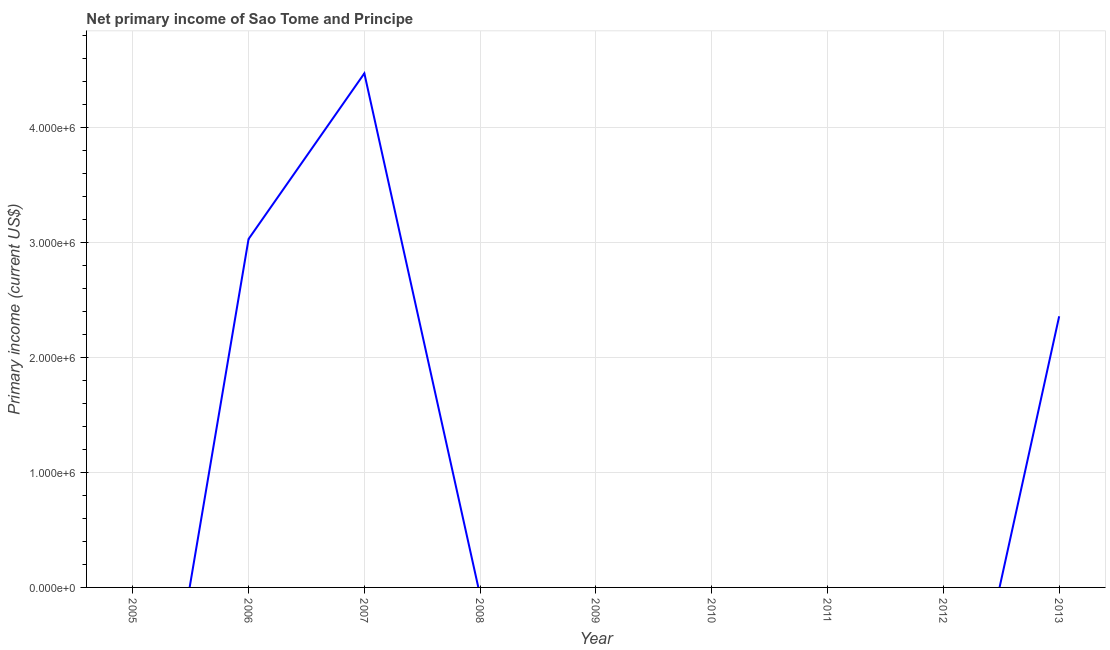What is the amount of primary income in 2013?
Your answer should be very brief. 2.36e+06. Across all years, what is the maximum amount of primary income?
Give a very brief answer. 4.47e+06. Across all years, what is the minimum amount of primary income?
Ensure brevity in your answer.  0. In which year was the amount of primary income maximum?
Keep it short and to the point. 2007. What is the sum of the amount of primary income?
Provide a short and direct response. 9.87e+06. What is the difference between the amount of primary income in 2007 and 2013?
Your response must be concise. 2.11e+06. What is the average amount of primary income per year?
Provide a succinct answer. 1.10e+06. What is the median amount of primary income?
Make the answer very short. 0. In how many years, is the amount of primary income greater than 4600000 US$?
Make the answer very short. 0. What is the ratio of the amount of primary income in 2007 to that in 2013?
Your response must be concise. 1.9. Is the amount of primary income in 2006 less than that in 2007?
Provide a succinct answer. Yes. What is the difference between the highest and the second highest amount of primary income?
Your answer should be compact. 1.44e+06. What is the difference between the highest and the lowest amount of primary income?
Provide a short and direct response. 4.47e+06. In how many years, is the amount of primary income greater than the average amount of primary income taken over all years?
Provide a short and direct response. 3. Does the amount of primary income monotonically increase over the years?
Offer a very short reply. No. How many lines are there?
Provide a short and direct response. 1. How many years are there in the graph?
Keep it short and to the point. 9. What is the difference between two consecutive major ticks on the Y-axis?
Provide a succinct answer. 1.00e+06. Are the values on the major ticks of Y-axis written in scientific E-notation?
Your answer should be compact. Yes. Does the graph contain any zero values?
Your response must be concise. Yes. Does the graph contain grids?
Keep it short and to the point. Yes. What is the title of the graph?
Provide a short and direct response. Net primary income of Sao Tome and Principe. What is the label or title of the X-axis?
Offer a terse response. Year. What is the label or title of the Y-axis?
Offer a very short reply. Primary income (current US$). What is the Primary income (current US$) of 2005?
Offer a very short reply. 0. What is the Primary income (current US$) of 2006?
Provide a succinct answer. 3.03e+06. What is the Primary income (current US$) in 2007?
Your answer should be very brief. 4.47e+06. What is the Primary income (current US$) in 2013?
Provide a short and direct response. 2.36e+06. What is the difference between the Primary income (current US$) in 2006 and 2007?
Your answer should be compact. -1.44e+06. What is the difference between the Primary income (current US$) in 2006 and 2013?
Your response must be concise. 6.72e+05. What is the difference between the Primary income (current US$) in 2007 and 2013?
Ensure brevity in your answer.  2.11e+06. What is the ratio of the Primary income (current US$) in 2006 to that in 2007?
Give a very brief answer. 0.68. What is the ratio of the Primary income (current US$) in 2006 to that in 2013?
Your answer should be very brief. 1.28. What is the ratio of the Primary income (current US$) in 2007 to that in 2013?
Ensure brevity in your answer.  1.9. 